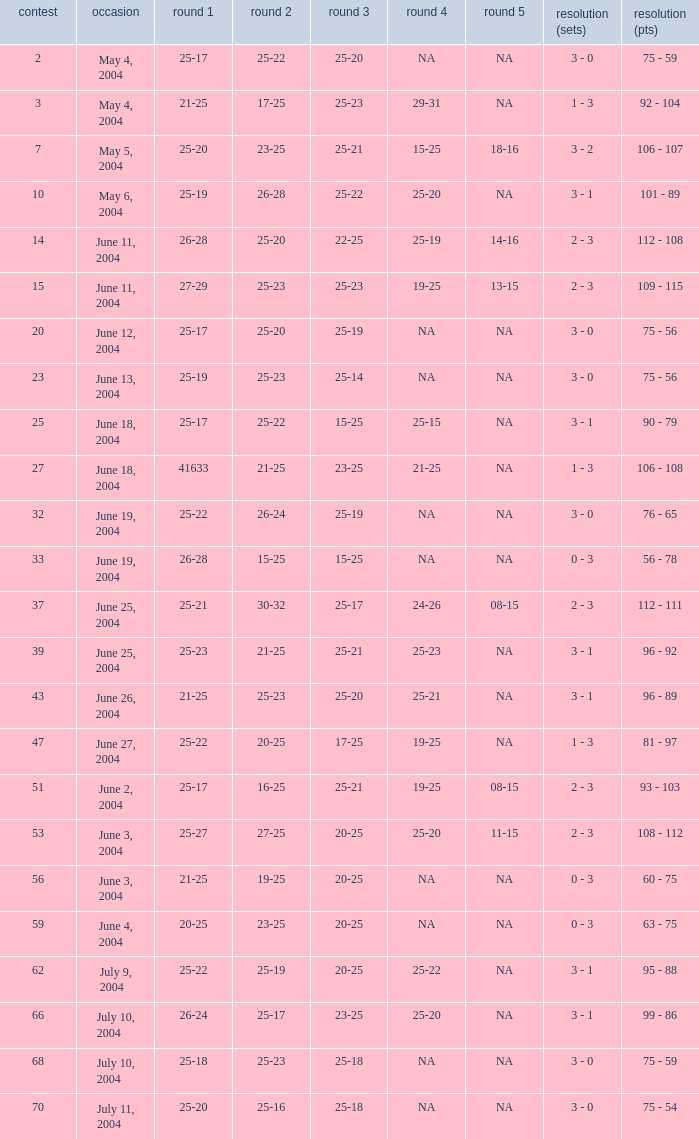What is the set 5 for the game with a set 2 of 21-25 and a set 1 of 41633? NA. 